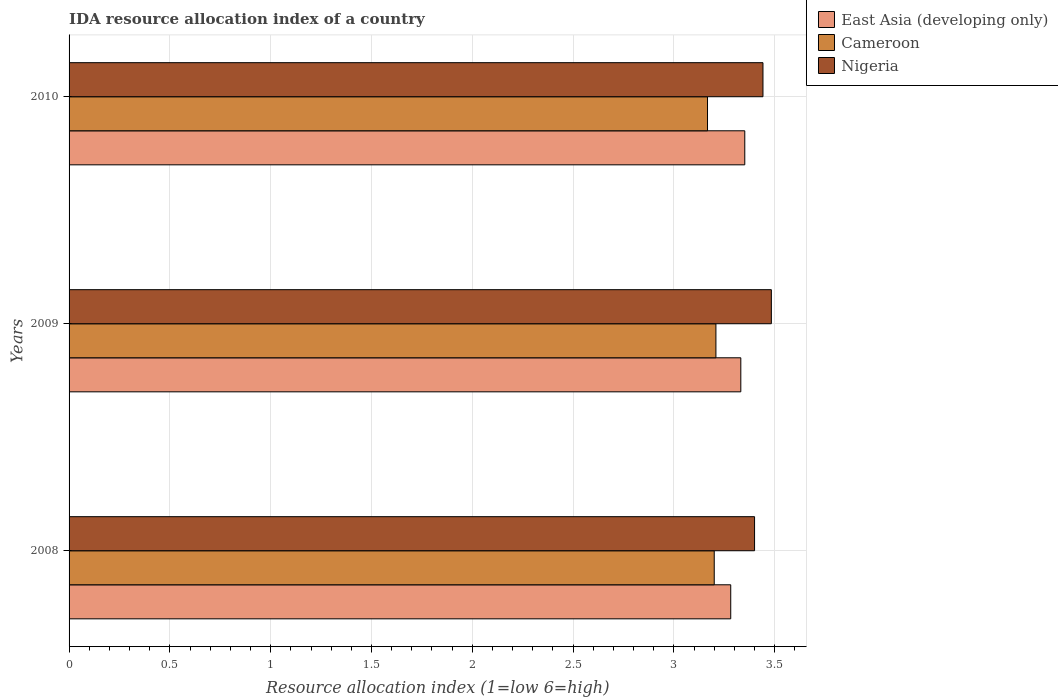How many different coloured bars are there?
Provide a short and direct response. 3. How many groups of bars are there?
Offer a very short reply. 3. Are the number of bars per tick equal to the number of legend labels?
Offer a very short reply. Yes. Are the number of bars on each tick of the Y-axis equal?
Give a very brief answer. Yes. How many bars are there on the 3rd tick from the bottom?
Provide a succinct answer. 3. What is the IDA resource allocation index in Cameroon in 2010?
Provide a short and direct response. 3.17. Across all years, what is the maximum IDA resource allocation index in East Asia (developing only)?
Your response must be concise. 3.35. Across all years, what is the minimum IDA resource allocation index in East Asia (developing only)?
Provide a succinct answer. 3.28. What is the total IDA resource allocation index in Cameroon in the graph?
Your response must be concise. 9.57. What is the difference between the IDA resource allocation index in East Asia (developing only) in 2008 and that in 2009?
Provide a succinct answer. -0.05. What is the difference between the IDA resource allocation index in Cameroon in 2009 and the IDA resource allocation index in Nigeria in 2008?
Ensure brevity in your answer.  -0.19. What is the average IDA resource allocation index in East Asia (developing only) per year?
Give a very brief answer. 3.32. In the year 2009, what is the difference between the IDA resource allocation index in Nigeria and IDA resource allocation index in East Asia (developing only)?
Your answer should be compact. 0.15. What is the ratio of the IDA resource allocation index in East Asia (developing only) in 2009 to that in 2010?
Your answer should be compact. 0.99. Is the IDA resource allocation index in Cameroon in 2008 less than that in 2010?
Offer a terse response. No. Is the difference between the IDA resource allocation index in Nigeria in 2009 and 2010 greater than the difference between the IDA resource allocation index in East Asia (developing only) in 2009 and 2010?
Give a very brief answer. Yes. What is the difference between the highest and the second highest IDA resource allocation index in Cameroon?
Your response must be concise. 0.01. What is the difference between the highest and the lowest IDA resource allocation index in Nigeria?
Keep it short and to the point. 0.08. In how many years, is the IDA resource allocation index in East Asia (developing only) greater than the average IDA resource allocation index in East Asia (developing only) taken over all years?
Offer a terse response. 2. What does the 3rd bar from the top in 2008 represents?
Your response must be concise. East Asia (developing only). What does the 1st bar from the bottom in 2009 represents?
Your answer should be very brief. East Asia (developing only). Is it the case that in every year, the sum of the IDA resource allocation index in Nigeria and IDA resource allocation index in East Asia (developing only) is greater than the IDA resource allocation index in Cameroon?
Ensure brevity in your answer.  Yes. How many years are there in the graph?
Offer a terse response. 3. What is the difference between two consecutive major ticks on the X-axis?
Your answer should be very brief. 0.5. Does the graph contain any zero values?
Your response must be concise. No. Does the graph contain grids?
Provide a succinct answer. Yes. What is the title of the graph?
Provide a short and direct response. IDA resource allocation index of a country. Does "Latin America(all income levels)" appear as one of the legend labels in the graph?
Your response must be concise. No. What is the label or title of the X-axis?
Provide a succinct answer. Resource allocation index (1=low 6=high). What is the Resource allocation index (1=low 6=high) in East Asia (developing only) in 2008?
Your answer should be very brief. 3.28. What is the Resource allocation index (1=low 6=high) in Nigeria in 2008?
Your answer should be compact. 3.4. What is the Resource allocation index (1=low 6=high) of East Asia (developing only) in 2009?
Provide a short and direct response. 3.33. What is the Resource allocation index (1=low 6=high) of Cameroon in 2009?
Offer a terse response. 3.21. What is the Resource allocation index (1=low 6=high) in Nigeria in 2009?
Give a very brief answer. 3.48. What is the Resource allocation index (1=low 6=high) in East Asia (developing only) in 2010?
Your answer should be compact. 3.35. What is the Resource allocation index (1=low 6=high) of Cameroon in 2010?
Keep it short and to the point. 3.17. What is the Resource allocation index (1=low 6=high) in Nigeria in 2010?
Ensure brevity in your answer.  3.44. Across all years, what is the maximum Resource allocation index (1=low 6=high) in East Asia (developing only)?
Your answer should be compact. 3.35. Across all years, what is the maximum Resource allocation index (1=low 6=high) of Cameroon?
Your answer should be compact. 3.21. Across all years, what is the maximum Resource allocation index (1=low 6=high) in Nigeria?
Make the answer very short. 3.48. Across all years, what is the minimum Resource allocation index (1=low 6=high) in East Asia (developing only)?
Offer a terse response. 3.28. Across all years, what is the minimum Resource allocation index (1=low 6=high) of Cameroon?
Make the answer very short. 3.17. What is the total Resource allocation index (1=low 6=high) in East Asia (developing only) in the graph?
Offer a very short reply. 9.97. What is the total Resource allocation index (1=low 6=high) of Cameroon in the graph?
Your answer should be compact. 9.57. What is the total Resource allocation index (1=low 6=high) in Nigeria in the graph?
Provide a succinct answer. 10.32. What is the difference between the Resource allocation index (1=low 6=high) of East Asia (developing only) in 2008 and that in 2009?
Provide a short and direct response. -0.05. What is the difference between the Resource allocation index (1=low 6=high) in Cameroon in 2008 and that in 2009?
Provide a short and direct response. -0.01. What is the difference between the Resource allocation index (1=low 6=high) of Nigeria in 2008 and that in 2009?
Provide a short and direct response. -0.08. What is the difference between the Resource allocation index (1=low 6=high) of East Asia (developing only) in 2008 and that in 2010?
Keep it short and to the point. -0.07. What is the difference between the Resource allocation index (1=low 6=high) in Nigeria in 2008 and that in 2010?
Give a very brief answer. -0.04. What is the difference between the Resource allocation index (1=low 6=high) of East Asia (developing only) in 2009 and that in 2010?
Ensure brevity in your answer.  -0.02. What is the difference between the Resource allocation index (1=low 6=high) in Cameroon in 2009 and that in 2010?
Ensure brevity in your answer.  0.04. What is the difference between the Resource allocation index (1=low 6=high) of Nigeria in 2009 and that in 2010?
Offer a very short reply. 0.04. What is the difference between the Resource allocation index (1=low 6=high) in East Asia (developing only) in 2008 and the Resource allocation index (1=low 6=high) in Cameroon in 2009?
Keep it short and to the point. 0.07. What is the difference between the Resource allocation index (1=low 6=high) of East Asia (developing only) in 2008 and the Resource allocation index (1=low 6=high) of Nigeria in 2009?
Offer a very short reply. -0.2. What is the difference between the Resource allocation index (1=low 6=high) in Cameroon in 2008 and the Resource allocation index (1=low 6=high) in Nigeria in 2009?
Offer a very short reply. -0.28. What is the difference between the Resource allocation index (1=low 6=high) of East Asia (developing only) in 2008 and the Resource allocation index (1=low 6=high) of Cameroon in 2010?
Make the answer very short. 0.12. What is the difference between the Resource allocation index (1=low 6=high) in East Asia (developing only) in 2008 and the Resource allocation index (1=low 6=high) in Nigeria in 2010?
Provide a succinct answer. -0.16. What is the difference between the Resource allocation index (1=low 6=high) in Cameroon in 2008 and the Resource allocation index (1=low 6=high) in Nigeria in 2010?
Offer a very short reply. -0.24. What is the difference between the Resource allocation index (1=low 6=high) of East Asia (developing only) in 2009 and the Resource allocation index (1=low 6=high) of Cameroon in 2010?
Give a very brief answer. 0.17. What is the difference between the Resource allocation index (1=low 6=high) of East Asia (developing only) in 2009 and the Resource allocation index (1=low 6=high) of Nigeria in 2010?
Ensure brevity in your answer.  -0.11. What is the difference between the Resource allocation index (1=low 6=high) in Cameroon in 2009 and the Resource allocation index (1=low 6=high) in Nigeria in 2010?
Keep it short and to the point. -0.23. What is the average Resource allocation index (1=low 6=high) in East Asia (developing only) per year?
Your response must be concise. 3.32. What is the average Resource allocation index (1=low 6=high) in Cameroon per year?
Make the answer very short. 3.19. What is the average Resource allocation index (1=low 6=high) of Nigeria per year?
Provide a short and direct response. 3.44. In the year 2008, what is the difference between the Resource allocation index (1=low 6=high) in East Asia (developing only) and Resource allocation index (1=low 6=high) in Cameroon?
Offer a very short reply. 0.08. In the year 2008, what is the difference between the Resource allocation index (1=low 6=high) in East Asia (developing only) and Resource allocation index (1=low 6=high) in Nigeria?
Provide a succinct answer. -0.12. In the year 2009, what is the difference between the Resource allocation index (1=low 6=high) of East Asia (developing only) and Resource allocation index (1=low 6=high) of Cameroon?
Offer a very short reply. 0.12. In the year 2009, what is the difference between the Resource allocation index (1=low 6=high) in East Asia (developing only) and Resource allocation index (1=low 6=high) in Nigeria?
Offer a very short reply. -0.15. In the year 2009, what is the difference between the Resource allocation index (1=low 6=high) in Cameroon and Resource allocation index (1=low 6=high) in Nigeria?
Give a very brief answer. -0.28. In the year 2010, what is the difference between the Resource allocation index (1=low 6=high) of East Asia (developing only) and Resource allocation index (1=low 6=high) of Cameroon?
Make the answer very short. 0.18. In the year 2010, what is the difference between the Resource allocation index (1=low 6=high) in East Asia (developing only) and Resource allocation index (1=low 6=high) in Nigeria?
Your response must be concise. -0.09. In the year 2010, what is the difference between the Resource allocation index (1=low 6=high) in Cameroon and Resource allocation index (1=low 6=high) in Nigeria?
Your response must be concise. -0.28. What is the ratio of the Resource allocation index (1=low 6=high) of East Asia (developing only) in 2008 to that in 2009?
Offer a very short reply. 0.98. What is the ratio of the Resource allocation index (1=low 6=high) of Cameroon in 2008 to that in 2009?
Keep it short and to the point. 1. What is the ratio of the Resource allocation index (1=low 6=high) of Nigeria in 2008 to that in 2009?
Ensure brevity in your answer.  0.98. What is the ratio of the Resource allocation index (1=low 6=high) in East Asia (developing only) in 2008 to that in 2010?
Offer a terse response. 0.98. What is the ratio of the Resource allocation index (1=low 6=high) of Cameroon in 2008 to that in 2010?
Your answer should be compact. 1.01. What is the ratio of the Resource allocation index (1=low 6=high) of Nigeria in 2008 to that in 2010?
Provide a succinct answer. 0.99. What is the ratio of the Resource allocation index (1=low 6=high) of East Asia (developing only) in 2009 to that in 2010?
Make the answer very short. 0.99. What is the ratio of the Resource allocation index (1=low 6=high) in Cameroon in 2009 to that in 2010?
Keep it short and to the point. 1.01. What is the ratio of the Resource allocation index (1=low 6=high) of Nigeria in 2009 to that in 2010?
Provide a succinct answer. 1.01. What is the difference between the highest and the second highest Resource allocation index (1=low 6=high) in East Asia (developing only)?
Offer a very short reply. 0.02. What is the difference between the highest and the second highest Resource allocation index (1=low 6=high) of Cameroon?
Provide a succinct answer. 0.01. What is the difference between the highest and the second highest Resource allocation index (1=low 6=high) in Nigeria?
Your response must be concise. 0.04. What is the difference between the highest and the lowest Resource allocation index (1=low 6=high) in East Asia (developing only)?
Provide a short and direct response. 0.07. What is the difference between the highest and the lowest Resource allocation index (1=low 6=high) of Cameroon?
Your answer should be compact. 0.04. What is the difference between the highest and the lowest Resource allocation index (1=low 6=high) of Nigeria?
Your answer should be compact. 0.08. 